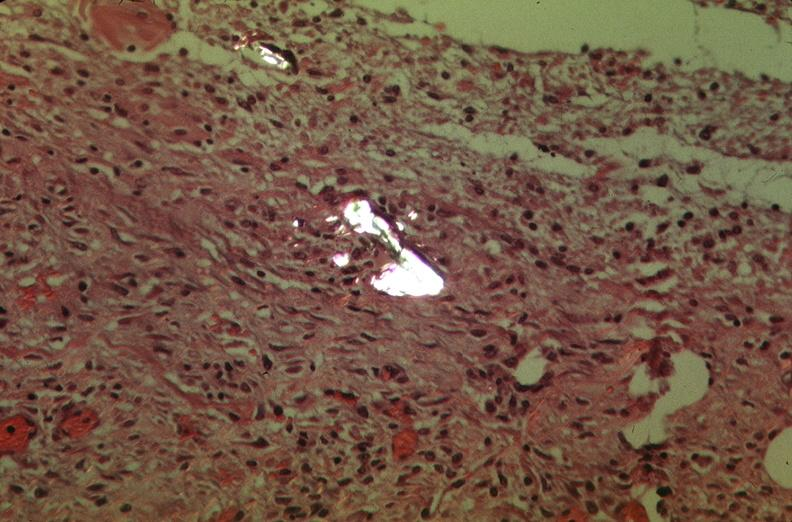does this image show pleura, talc reaction showing talc birefringence?
Answer the question using a single word or phrase. Yes 